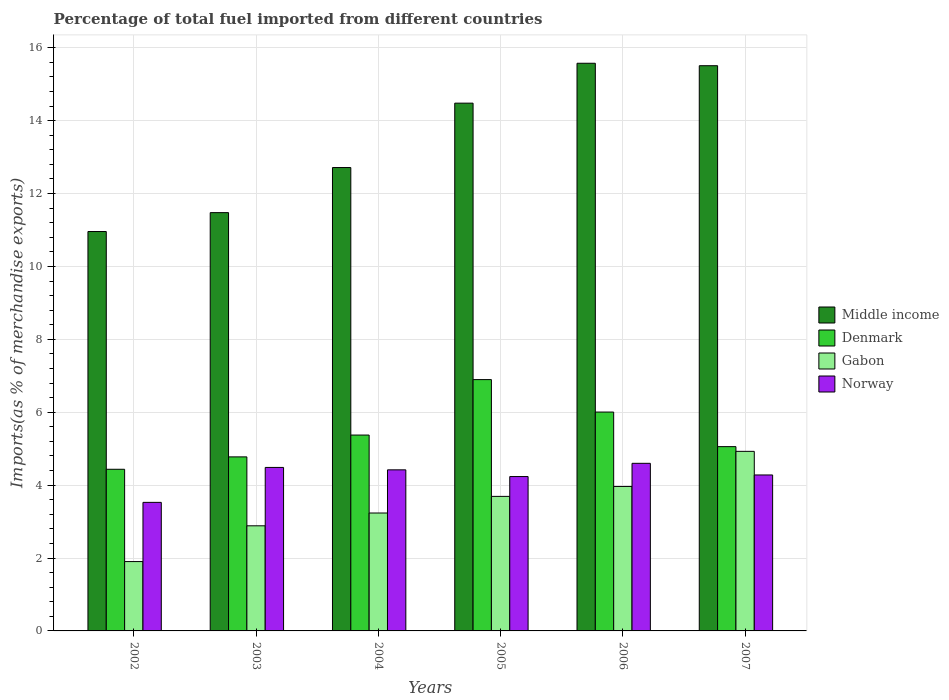How many different coloured bars are there?
Your answer should be compact. 4. How many groups of bars are there?
Provide a short and direct response. 6. Are the number of bars on each tick of the X-axis equal?
Your answer should be compact. Yes. In how many cases, is the number of bars for a given year not equal to the number of legend labels?
Your answer should be very brief. 0. What is the percentage of imports to different countries in Denmark in 2005?
Your response must be concise. 6.9. Across all years, what is the maximum percentage of imports to different countries in Gabon?
Provide a succinct answer. 4.93. Across all years, what is the minimum percentage of imports to different countries in Middle income?
Your response must be concise. 10.96. What is the total percentage of imports to different countries in Denmark in the graph?
Provide a short and direct response. 32.54. What is the difference between the percentage of imports to different countries in Denmark in 2005 and that in 2006?
Your answer should be compact. 0.89. What is the difference between the percentage of imports to different countries in Norway in 2005 and the percentage of imports to different countries in Middle income in 2003?
Provide a succinct answer. -7.24. What is the average percentage of imports to different countries in Middle income per year?
Your response must be concise. 13.45. In the year 2004, what is the difference between the percentage of imports to different countries in Norway and percentage of imports to different countries in Middle income?
Give a very brief answer. -8.29. In how many years, is the percentage of imports to different countries in Gabon greater than 9.6 %?
Give a very brief answer. 0. What is the ratio of the percentage of imports to different countries in Middle income in 2005 to that in 2006?
Your response must be concise. 0.93. Is the difference between the percentage of imports to different countries in Norway in 2004 and 2006 greater than the difference between the percentage of imports to different countries in Middle income in 2004 and 2006?
Make the answer very short. Yes. What is the difference between the highest and the second highest percentage of imports to different countries in Denmark?
Give a very brief answer. 0.89. What is the difference between the highest and the lowest percentage of imports to different countries in Norway?
Keep it short and to the point. 1.07. What does the 4th bar from the left in 2007 represents?
Your response must be concise. Norway. Is it the case that in every year, the sum of the percentage of imports to different countries in Gabon and percentage of imports to different countries in Norway is greater than the percentage of imports to different countries in Denmark?
Your answer should be very brief. Yes. How many bars are there?
Provide a short and direct response. 24. Are all the bars in the graph horizontal?
Provide a succinct answer. No. How many years are there in the graph?
Make the answer very short. 6. What is the difference between two consecutive major ticks on the Y-axis?
Keep it short and to the point. 2. Are the values on the major ticks of Y-axis written in scientific E-notation?
Your answer should be very brief. No. Does the graph contain any zero values?
Give a very brief answer. No. Does the graph contain grids?
Give a very brief answer. Yes. How many legend labels are there?
Ensure brevity in your answer.  4. What is the title of the graph?
Your response must be concise. Percentage of total fuel imported from different countries. What is the label or title of the Y-axis?
Offer a terse response. Imports(as % of merchandise exports). What is the Imports(as % of merchandise exports) in Middle income in 2002?
Ensure brevity in your answer.  10.96. What is the Imports(as % of merchandise exports) of Denmark in 2002?
Provide a succinct answer. 4.44. What is the Imports(as % of merchandise exports) of Gabon in 2002?
Keep it short and to the point. 1.9. What is the Imports(as % of merchandise exports) in Norway in 2002?
Give a very brief answer. 3.53. What is the Imports(as % of merchandise exports) in Middle income in 2003?
Keep it short and to the point. 11.48. What is the Imports(as % of merchandise exports) of Denmark in 2003?
Make the answer very short. 4.77. What is the Imports(as % of merchandise exports) of Gabon in 2003?
Provide a short and direct response. 2.88. What is the Imports(as % of merchandise exports) of Norway in 2003?
Your answer should be very brief. 4.49. What is the Imports(as % of merchandise exports) in Middle income in 2004?
Provide a succinct answer. 12.71. What is the Imports(as % of merchandise exports) in Denmark in 2004?
Your answer should be very brief. 5.37. What is the Imports(as % of merchandise exports) of Gabon in 2004?
Provide a short and direct response. 3.23. What is the Imports(as % of merchandise exports) of Norway in 2004?
Make the answer very short. 4.42. What is the Imports(as % of merchandise exports) in Middle income in 2005?
Give a very brief answer. 14.48. What is the Imports(as % of merchandise exports) of Denmark in 2005?
Your answer should be very brief. 6.9. What is the Imports(as % of merchandise exports) in Gabon in 2005?
Your answer should be very brief. 3.69. What is the Imports(as % of merchandise exports) in Norway in 2005?
Offer a terse response. 4.24. What is the Imports(as % of merchandise exports) in Middle income in 2006?
Provide a succinct answer. 15.57. What is the Imports(as % of merchandise exports) in Denmark in 2006?
Offer a terse response. 6. What is the Imports(as % of merchandise exports) of Gabon in 2006?
Make the answer very short. 3.96. What is the Imports(as % of merchandise exports) in Norway in 2006?
Provide a short and direct response. 4.6. What is the Imports(as % of merchandise exports) of Middle income in 2007?
Offer a terse response. 15.51. What is the Imports(as % of merchandise exports) of Denmark in 2007?
Ensure brevity in your answer.  5.06. What is the Imports(as % of merchandise exports) in Gabon in 2007?
Provide a short and direct response. 4.93. What is the Imports(as % of merchandise exports) in Norway in 2007?
Ensure brevity in your answer.  4.28. Across all years, what is the maximum Imports(as % of merchandise exports) of Middle income?
Make the answer very short. 15.57. Across all years, what is the maximum Imports(as % of merchandise exports) of Denmark?
Offer a very short reply. 6.9. Across all years, what is the maximum Imports(as % of merchandise exports) of Gabon?
Provide a short and direct response. 4.93. Across all years, what is the maximum Imports(as % of merchandise exports) of Norway?
Keep it short and to the point. 4.6. Across all years, what is the minimum Imports(as % of merchandise exports) of Middle income?
Give a very brief answer. 10.96. Across all years, what is the minimum Imports(as % of merchandise exports) of Denmark?
Your response must be concise. 4.44. Across all years, what is the minimum Imports(as % of merchandise exports) in Gabon?
Provide a succinct answer. 1.9. Across all years, what is the minimum Imports(as % of merchandise exports) in Norway?
Offer a very short reply. 3.53. What is the total Imports(as % of merchandise exports) in Middle income in the graph?
Offer a very short reply. 80.71. What is the total Imports(as % of merchandise exports) in Denmark in the graph?
Give a very brief answer. 32.54. What is the total Imports(as % of merchandise exports) in Gabon in the graph?
Offer a very short reply. 20.6. What is the total Imports(as % of merchandise exports) of Norway in the graph?
Provide a succinct answer. 25.54. What is the difference between the Imports(as % of merchandise exports) in Middle income in 2002 and that in 2003?
Your answer should be very brief. -0.52. What is the difference between the Imports(as % of merchandise exports) of Denmark in 2002 and that in 2003?
Your answer should be very brief. -0.34. What is the difference between the Imports(as % of merchandise exports) in Gabon in 2002 and that in 2003?
Offer a very short reply. -0.98. What is the difference between the Imports(as % of merchandise exports) of Norway in 2002 and that in 2003?
Offer a very short reply. -0.96. What is the difference between the Imports(as % of merchandise exports) in Middle income in 2002 and that in 2004?
Your answer should be very brief. -1.76. What is the difference between the Imports(as % of merchandise exports) in Denmark in 2002 and that in 2004?
Your answer should be compact. -0.94. What is the difference between the Imports(as % of merchandise exports) in Gabon in 2002 and that in 2004?
Ensure brevity in your answer.  -1.33. What is the difference between the Imports(as % of merchandise exports) of Norway in 2002 and that in 2004?
Provide a short and direct response. -0.89. What is the difference between the Imports(as % of merchandise exports) of Middle income in 2002 and that in 2005?
Ensure brevity in your answer.  -3.52. What is the difference between the Imports(as % of merchandise exports) of Denmark in 2002 and that in 2005?
Ensure brevity in your answer.  -2.46. What is the difference between the Imports(as % of merchandise exports) in Gabon in 2002 and that in 2005?
Provide a short and direct response. -1.79. What is the difference between the Imports(as % of merchandise exports) in Norway in 2002 and that in 2005?
Give a very brief answer. -0.71. What is the difference between the Imports(as % of merchandise exports) in Middle income in 2002 and that in 2006?
Your response must be concise. -4.62. What is the difference between the Imports(as % of merchandise exports) in Denmark in 2002 and that in 2006?
Give a very brief answer. -1.57. What is the difference between the Imports(as % of merchandise exports) of Gabon in 2002 and that in 2006?
Ensure brevity in your answer.  -2.06. What is the difference between the Imports(as % of merchandise exports) of Norway in 2002 and that in 2006?
Your answer should be compact. -1.07. What is the difference between the Imports(as % of merchandise exports) of Middle income in 2002 and that in 2007?
Ensure brevity in your answer.  -4.55. What is the difference between the Imports(as % of merchandise exports) of Denmark in 2002 and that in 2007?
Make the answer very short. -0.62. What is the difference between the Imports(as % of merchandise exports) in Gabon in 2002 and that in 2007?
Provide a short and direct response. -3.02. What is the difference between the Imports(as % of merchandise exports) of Norway in 2002 and that in 2007?
Offer a terse response. -0.75. What is the difference between the Imports(as % of merchandise exports) in Middle income in 2003 and that in 2004?
Your answer should be very brief. -1.24. What is the difference between the Imports(as % of merchandise exports) in Denmark in 2003 and that in 2004?
Give a very brief answer. -0.6. What is the difference between the Imports(as % of merchandise exports) of Gabon in 2003 and that in 2004?
Offer a very short reply. -0.35. What is the difference between the Imports(as % of merchandise exports) of Norway in 2003 and that in 2004?
Keep it short and to the point. 0.07. What is the difference between the Imports(as % of merchandise exports) in Middle income in 2003 and that in 2005?
Offer a very short reply. -3. What is the difference between the Imports(as % of merchandise exports) in Denmark in 2003 and that in 2005?
Ensure brevity in your answer.  -2.12. What is the difference between the Imports(as % of merchandise exports) of Gabon in 2003 and that in 2005?
Offer a terse response. -0.81. What is the difference between the Imports(as % of merchandise exports) in Norway in 2003 and that in 2005?
Offer a very short reply. 0.25. What is the difference between the Imports(as % of merchandise exports) of Middle income in 2003 and that in 2006?
Ensure brevity in your answer.  -4.1. What is the difference between the Imports(as % of merchandise exports) of Denmark in 2003 and that in 2006?
Your answer should be compact. -1.23. What is the difference between the Imports(as % of merchandise exports) of Gabon in 2003 and that in 2006?
Provide a succinct answer. -1.08. What is the difference between the Imports(as % of merchandise exports) in Norway in 2003 and that in 2006?
Offer a very short reply. -0.11. What is the difference between the Imports(as % of merchandise exports) of Middle income in 2003 and that in 2007?
Your response must be concise. -4.03. What is the difference between the Imports(as % of merchandise exports) of Denmark in 2003 and that in 2007?
Your answer should be compact. -0.28. What is the difference between the Imports(as % of merchandise exports) of Gabon in 2003 and that in 2007?
Provide a short and direct response. -2.04. What is the difference between the Imports(as % of merchandise exports) in Norway in 2003 and that in 2007?
Offer a terse response. 0.21. What is the difference between the Imports(as % of merchandise exports) in Middle income in 2004 and that in 2005?
Ensure brevity in your answer.  -1.77. What is the difference between the Imports(as % of merchandise exports) in Denmark in 2004 and that in 2005?
Make the answer very short. -1.52. What is the difference between the Imports(as % of merchandise exports) of Gabon in 2004 and that in 2005?
Give a very brief answer. -0.46. What is the difference between the Imports(as % of merchandise exports) in Norway in 2004 and that in 2005?
Your answer should be very brief. 0.18. What is the difference between the Imports(as % of merchandise exports) in Middle income in 2004 and that in 2006?
Give a very brief answer. -2.86. What is the difference between the Imports(as % of merchandise exports) of Denmark in 2004 and that in 2006?
Offer a terse response. -0.63. What is the difference between the Imports(as % of merchandise exports) of Gabon in 2004 and that in 2006?
Provide a short and direct response. -0.73. What is the difference between the Imports(as % of merchandise exports) of Norway in 2004 and that in 2006?
Offer a very short reply. -0.18. What is the difference between the Imports(as % of merchandise exports) of Middle income in 2004 and that in 2007?
Keep it short and to the point. -2.79. What is the difference between the Imports(as % of merchandise exports) of Denmark in 2004 and that in 2007?
Offer a very short reply. 0.32. What is the difference between the Imports(as % of merchandise exports) of Gabon in 2004 and that in 2007?
Keep it short and to the point. -1.69. What is the difference between the Imports(as % of merchandise exports) in Norway in 2004 and that in 2007?
Your answer should be very brief. 0.14. What is the difference between the Imports(as % of merchandise exports) of Middle income in 2005 and that in 2006?
Offer a very short reply. -1.09. What is the difference between the Imports(as % of merchandise exports) of Denmark in 2005 and that in 2006?
Offer a very short reply. 0.89. What is the difference between the Imports(as % of merchandise exports) in Gabon in 2005 and that in 2006?
Provide a short and direct response. -0.27. What is the difference between the Imports(as % of merchandise exports) of Norway in 2005 and that in 2006?
Make the answer very short. -0.36. What is the difference between the Imports(as % of merchandise exports) of Middle income in 2005 and that in 2007?
Keep it short and to the point. -1.03. What is the difference between the Imports(as % of merchandise exports) in Denmark in 2005 and that in 2007?
Your answer should be very brief. 1.84. What is the difference between the Imports(as % of merchandise exports) of Gabon in 2005 and that in 2007?
Make the answer very short. -1.24. What is the difference between the Imports(as % of merchandise exports) of Norway in 2005 and that in 2007?
Your response must be concise. -0.04. What is the difference between the Imports(as % of merchandise exports) of Middle income in 2006 and that in 2007?
Your response must be concise. 0.07. What is the difference between the Imports(as % of merchandise exports) in Denmark in 2006 and that in 2007?
Give a very brief answer. 0.95. What is the difference between the Imports(as % of merchandise exports) of Gabon in 2006 and that in 2007?
Make the answer very short. -0.96. What is the difference between the Imports(as % of merchandise exports) in Norway in 2006 and that in 2007?
Provide a succinct answer. 0.32. What is the difference between the Imports(as % of merchandise exports) in Middle income in 2002 and the Imports(as % of merchandise exports) in Denmark in 2003?
Give a very brief answer. 6.18. What is the difference between the Imports(as % of merchandise exports) in Middle income in 2002 and the Imports(as % of merchandise exports) in Gabon in 2003?
Give a very brief answer. 8.07. What is the difference between the Imports(as % of merchandise exports) in Middle income in 2002 and the Imports(as % of merchandise exports) in Norway in 2003?
Give a very brief answer. 6.47. What is the difference between the Imports(as % of merchandise exports) of Denmark in 2002 and the Imports(as % of merchandise exports) of Gabon in 2003?
Give a very brief answer. 1.55. What is the difference between the Imports(as % of merchandise exports) of Denmark in 2002 and the Imports(as % of merchandise exports) of Norway in 2003?
Your response must be concise. -0.05. What is the difference between the Imports(as % of merchandise exports) of Gabon in 2002 and the Imports(as % of merchandise exports) of Norway in 2003?
Ensure brevity in your answer.  -2.58. What is the difference between the Imports(as % of merchandise exports) of Middle income in 2002 and the Imports(as % of merchandise exports) of Denmark in 2004?
Make the answer very short. 5.58. What is the difference between the Imports(as % of merchandise exports) in Middle income in 2002 and the Imports(as % of merchandise exports) in Gabon in 2004?
Give a very brief answer. 7.72. What is the difference between the Imports(as % of merchandise exports) in Middle income in 2002 and the Imports(as % of merchandise exports) in Norway in 2004?
Your answer should be compact. 6.54. What is the difference between the Imports(as % of merchandise exports) of Denmark in 2002 and the Imports(as % of merchandise exports) of Gabon in 2004?
Keep it short and to the point. 1.2. What is the difference between the Imports(as % of merchandise exports) in Denmark in 2002 and the Imports(as % of merchandise exports) in Norway in 2004?
Make the answer very short. 0.02. What is the difference between the Imports(as % of merchandise exports) of Gabon in 2002 and the Imports(as % of merchandise exports) of Norway in 2004?
Offer a very short reply. -2.52. What is the difference between the Imports(as % of merchandise exports) of Middle income in 2002 and the Imports(as % of merchandise exports) of Denmark in 2005?
Offer a terse response. 4.06. What is the difference between the Imports(as % of merchandise exports) in Middle income in 2002 and the Imports(as % of merchandise exports) in Gabon in 2005?
Provide a short and direct response. 7.27. What is the difference between the Imports(as % of merchandise exports) of Middle income in 2002 and the Imports(as % of merchandise exports) of Norway in 2005?
Provide a short and direct response. 6.72. What is the difference between the Imports(as % of merchandise exports) of Denmark in 2002 and the Imports(as % of merchandise exports) of Gabon in 2005?
Ensure brevity in your answer.  0.74. What is the difference between the Imports(as % of merchandise exports) of Denmark in 2002 and the Imports(as % of merchandise exports) of Norway in 2005?
Keep it short and to the point. 0.2. What is the difference between the Imports(as % of merchandise exports) of Gabon in 2002 and the Imports(as % of merchandise exports) of Norway in 2005?
Make the answer very short. -2.33. What is the difference between the Imports(as % of merchandise exports) of Middle income in 2002 and the Imports(as % of merchandise exports) of Denmark in 2006?
Give a very brief answer. 4.95. What is the difference between the Imports(as % of merchandise exports) of Middle income in 2002 and the Imports(as % of merchandise exports) of Gabon in 2006?
Your response must be concise. 6.99. What is the difference between the Imports(as % of merchandise exports) of Middle income in 2002 and the Imports(as % of merchandise exports) of Norway in 2006?
Your answer should be very brief. 6.36. What is the difference between the Imports(as % of merchandise exports) of Denmark in 2002 and the Imports(as % of merchandise exports) of Gabon in 2006?
Offer a very short reply. 0.47. What is the difference between the Imports(as % of merchandise exports) of Denmark in 2002 and the Imports(as % of merchandise exports) of Norway in 2006?
Offer a very short reply. -0.16. What is the difference between the Imports(as % of merchandise exports) of Gabon in 2002 and the Imports(as % of merchandise exports) of Norway in 2006?
Your answer should be very brief. -2.7. What is the difference between the Imports(as % of merchandise exports) of Middle income in 2002 and the Imports(as % of merchandise exports) of Denmark in 2007?
Give a very brief answer. 5.9. What is the difference between the Imports(as % of merchandise exports) in Middle income in 2002 and the Imports(as % of merchandise exports) in Gabon in 2007?
Offer a terse response. 6.03. What is the difference between the Imports(as % of merchandise exports) of Middle income in 2002 and the Imports(as % of merchandise exports) of Norway in 2007?
Give a very brief answer. 6.68. What is the difference between the Imports(as % of merchandise exports) of Denmark in 2002 and the Imports(as % of merchandise exports) of Gabon in 2007?
Provide a short and direct response. -0.49. What is the difference between the Imports(as % of merchandise exports) of Denmark in 2002 and the Imports(as % of merchandise exports) of Norway in 2007?
Your answer should be very brief. 0.16. What is the difference between the Imports(as % of merchandise exports) of Gabon in 2002 and the Imports(as % of merchandise exports) of Norway in 2007?
Keep it short and to the point. -2.38. What is the difference between the Imports(as % of merchandise exports) in Middle income in 2003 and the Imports(as % of merchandise exports) in Denmark in 2004?
Your response must be concise. 6.1. What is the difference between the Imports(as % of merchandise exports) in Middle income in 2003 and the Imports(as % of merchandise exports) in Gabon in 2004?
Offer a terse response. 8.24. What is the difference between the Imports(as % of merchandise exports) of Middle income in 2003 and the Imports(as % of merchandise exports) of Norway in 2004?
Give a very brief answer. 7.06. What is the difference between the Imports(as % of merchandise exports) in Denmark in 2003 and the Imports(as % of merchandise exports) in Gabon in 2004?
Offer a very short reply. 1.54. What is the difference between the Imports(as % of merchandise exports) of Denmark in 2003 and the Imports(as % of merchandise exports) of Norway in 2004?
Give a very brief answer. 0.36. What is the difference between the Imports(as % of merchandise exports) of Gabon in 2003 and the Imports(as % of merchandise exports) of Norway in 2004?
Make the answer very short. -1.54. What is the difference between the Imports(as % of merchandise exports) of Middle income in 2003 and the Imports(as % of merchandise exports) of Denmark in 2005?
Provide a succinct answer. 4.58. What is the difference between the Imports(as % of merchandise exports) in Middle income in 2003 and the Imports(as % of merchandise exports) in Gabon in 2005?
Ensure brevity in your answer.  7.78. What is the difference between the Imports(as % of merchandise exports) of Middle income in 2003 and the Imports(as % of merchandise exports) of Norway in 2005?
Your answer should be compact. 7.24. What is the difference between the Imports(as % of merchandise exports) in Denmark in 2003 and the Imports(as % of merchandise exports) in Gabon in 2005?
Keep it short and to the point. 1.08. What is the difference between the Imports(as % of merchandise exports) in Denmark in 2003 and the Imports(as % of merchandise exports) in Norway in 2005?
Your response must be concise. 0.54. What is the difference between the Imports(as % of merchandise exports) in Gabon in 2003 and the Imports(as % of merchandise exports) in Norway in 2005?
Your response must be concise. -1.35. What is the difference between the Imports(as % of merchandise exports) of Middle income in 2003 and the Imports(as % of merchandise exports) of Denmark in 2006?
Offer a very short reply. 5.47. What is the difference between the Imports(as % of merchandise exports) of Middle income in 2003 and the Imports(as % of merchandise exports) of Gabon in 2006?
Make the answer very short. 7.51. What is the difference between the Imports(as % of merchandise exports) of Middle income in 2003 and the Imports(as % of merchandise exports) of Norway in 2006?
Make the answer very short. 6.88. What is the difference between the Imports(as % of merchandise exports) in Denmark in 2003 and the Imports(as % of merchandise exports) in Gabon in 2006?
Provide a succinct answer. 0.81. What is the difference between the Imports(as % of merchandise exports) of Denmark in 2003 and the Imports(as % of merchandise exports) of Norway in 2006?
Offer a terse response. 0.18. What is the difference between the Imports(as % of merchandise exports) in Gabon in 2003 and the Imports(as % of merchandise exports) in Norway in 2006?
Your response must be concise. -1.71. What is the difference between the Imports(as % of merchandise exports) of Middle income in 2003 and the Imports(as % of merchandise exports) of Denmark in 2007?
Offer a terse response. 6.42. What is the difference between the Imports(as % of merchandise exports) in Middle income in 2003 and the Imports(as % of merchandise exports) in Gabon in 2007?
Give a very brief answer. 6.55. What is the difference between the Imports(as % of merchandise exports) in Middle income in 2003 and the Imports(as % of merchandise exports) in Norway in 2007?
Your answer should be very brief. 7.2. What is the difference between the Imports(as % of merchandise exports) of Denmark in 2003 and the Imports(as % of merchandise exports) of Gabon in 2007?
Provide a short and direct response. -0.15. What is the difference between the Imports(as % of merchandise exports) in Denmark in 2003 and the Imports(as % of merchandise exports) in Norway in 2007?
Offer a terse response. 0.5. What is the difference between the Imports(as % of merchandise exports) of Gabon in 2003 and the Imports(as % of merchandise exports) of Norway in 2007?
Ensure brevity in your answer.  -1.4. What is the difference between the Imports(as % of merchandise exports) of Middle income in 2004 and the Imports(as % of merchandise exports) of Denmark in 2005?
Your answer should be compact. 5.82. What is the difference between the Imports(as % of merchandise exports) of Middle income in 2004 and the Imports(as % of merchandise exports) of Gabon in 2005?
Ensure brevity in your answer.  9.02. What is the difference between the Imports(as % of merchandise exports) in Middle income in 2004 and the Imports(as % of merchandise exports) in Norway in 2005?
Your answer should be very brief. 8.48. What is the difference between the Imports(as % of merchandise exports) in Denmark in 2004 and the Imports(as % of merchandise exports) in Gabon in 2005?
Provide a succinct answer. 1.68. What is the difference between the Imports(as % of merchandise exports) of Denmark in 2004 and the Imports(as % of merchandise exports) of Norway in 2005?
Provide a short and direct response. 1.14. What is the difference between the Imports(as % of merchandise exports) in Gabon in 2004 and the Imports(as % of merchandise exports) in Norway in 2005?
Give a very brief answer. -1. What is the difference between the Imports(as % of merchandise exports) of Middle income in 2004 and the Imports(as % of merchandise exports) of Denmark in 2006?
Offer a very short reply. 6.71. What is the difference between the Imports(as % of merchandise exports) of Middle income in 2004 and the Imports(as % of merchandise exports) of Gabon in 2006?
Provide a short and direct response. 8.75. What is the difference between the Imports(as % of merchandise exports) of Middle income in 2004 and the Imports(as % of merchandise exports) of Norway in 2006?
Your response must be concise. 8.12. What is the difference between the Imports(as % of merchandise exports) in Denmark in 2004 and the Imports(as % of merchandise exports) in Gabon in 2006?
Keep it short and to the point. 1.41. What is the difference between the Imports(as % of merchandise exports) of Denmark in 2004 and the Imports(as % of merchandise exports) of Norway in 2006?
Provide a short and direct response. 0.78. What is the difference between the Imports(as % of merchandise exports) in Gabon in 2004 and the Imports(as % of merchandise exports) in Norway in 2006?
Your response must be concise. -1.36. What is the difference between the Imports(as % of merchandise exports) in Middle income in 2004 and the Imports(as % of merchandise exports) in Denmark in 2007?
Your answer should be compact. 7.66. What is the difference between the Imports(as % of merchandise exports) in Middle income in 2004 and the Imports(as % of merchandise exports) in Gabon in 2007?
Provide a short and direct response. 7.79. What is the difference between the Imports(as % of merchandise exports) in Middle income in 2004 and the Imports(as % of merchandise exports) in Norway in 2007?
Your response must be concise. 8.43. What is the difference between the Imports(as % of merchandise exports) in Denmark in 2004 and the Imports(as % of merchandise exports) in Gabon in 2007?
Your answer should be very brief. 0.45. What is the difference between the Imports(as % of merchandise exports) in Denmark in 2004 and the Imports(as % of merchandise exports) in Norway in 2007?
Your answer should be compact. 1.09. What is the difference between the Imports(as % of merchandise exports) in Gabon in 2004 and the Imports(as % of merchandise exports) in Norway in 2007?
Offer a terse response. -1.04. What is the difference between the Imports(as % of merchandise exports) of Middle income in 2005 and the Imports(as % of merchandise exports) of Denmark in 2006?
Provide a short and direct response. 8.48. What is the difference between the Imports(as % of merchandise exports) of Middle income in 2005 and the Imports(as % of merchandise exports) of Gabon in 2006?
Give a very brief answer. 10.52. What is the difference between the Imports(as % of merchandise exports) of Middle income in 2005 and the Imports(as % of merchandise exports) of Norway in 2006?
Provide a succinct answer. 9.88. What is the difference between the Imports(as % of merchandise exports) in Denmark in 2005 and the Imports(as % of merchandise exports) in Gabon in 2006?
Your answer should be compact. 2.93. What is the difference between the Imports(as % of merchandise exports) of Denmark in 2005 and the Imports(as % of merchandise exports) of Norway in 2006?
Ensure brevity in your answer.  2.3. What is the difference between the Imports(as % of merchandise exports) of Gabon in 2005 and the Imports(as % of merchandise exports) of Norway in 2006?
Offer a very short reply. -0.91. What is the difference between the Imports(as % of merchandise exports) in Middle income in 2005 and the Imports(as % of merchandise exports) in Denmark in 2007?
Ensure brevity in your answer.  9.42. What is the difference between the Imports(as % of merchandise exports) in Middle income in 2005 and the Imports(as % of merchandise exports) in Gabon in 2007?
Your response must be concise. 9.55. What is the difference between the Imports(as % of merchandise exports) of Middle income in 2005 and the Imports(as % of merchandise exports) of Norway in 2007?
Your answer should be compact. 10.2. What is the difference between the Imports(as % of merchandise exports) in Denmark in 2005 and the Imports(as % of merchandise exports) in Gabon in 2007?
Provide a short and direct response. 1.97. What is the difference between the Imports(as % of merchandise exports) in Denmark in 2005 and the Imports(as % of merchandise exports) in Norway in 2007?
Give a very brief answer. 2.62. What is the difference between the Imports(as % of merchandise exports) in Gabon in 2005 and the Imports(as % of merchandise exports) in Norway in 2007?
Provide a short and direct response. -0.59. What is the difference between the Imports(as % of merchandise exports) in Middle income in 2006 and the Imports(as % of merchandise exports) in Denmark in 2007?
Provide a succinct answer. 10.52. What is the difference between the Imports(as % of merchandise exports) in Middle income in 2006 and the Imports(as % of merchandise exports) in Gabon in 2007?
Ensure brevity in your answer.  10.65. What is the difference between the Imports(as % of merchandise exports) of Middle income in 2006 and the Imports(as % of merchandise exports) of Norway in 2007?
Keep it short and to the point. 11.3. What is the difference between the Imports(as % of merchandise exports) in Denmark in 2006 and the Imports(as % of merchandise exports) in Gabon in 2007?
Ensure brevity in your answer.  1.08. What is the difference between the Imports(as % of merchandise exports) of Denmark in 2006 and the Imports(as % of merchandise exports) of Norway in 2007?
Ensure brevity in your answer.  1.73. What is the difference between the Imports(as % of merchandise exports) in Gabon in 2006 and the Imports(as % of merchandise exports) in Norway in 2007?
Your answer should be compact. -0.32. What is the average Imports(as % of merchandise exports) of Middle income per year?
Offer a terse response. 13.45. What is the average Imports(as % of merchandise exports) of Denmark per year?
Provide a succinct answer. 5.42. What is the average Imports(as % of merchandise exports) of Gabon per year?
Make the answer very short. 3.43. What is the average Imports(as % of merchandise exports) in Norway per year?
Offer a terse response. 4.26. In the year 2002, what is the difference between the Imports(as % of merchandise exports) in Middle income and Imports(as % of merchandise exports) in Denmark?
Offer a terse response. 6.52. In the year 2002, what is the difference between the Imports(as % of merchandise exports) of Middle income and Imports(as % of merchandise exports) of Gabon?
Offer a very short reply. 9.06. In the year 2002, what is the difference between the Imports(as % of merchandise exports) in Middle income and Imports(as % of merchandise exports) in Norway?
Provide a succinct answer. 7.43. In the year 2002, what is the difference between the Imports(as % of merchandise exports) of Denmark and Imports(as % of merchandise exports) of Gabon?
Offer a terse response. 2.53. In the year 2002, what is the difference between the Imports(as % of merchandise exports) of Denmark and Imports(as % of merchandise exports) of Norway?
Provide a succinct answer. 0.91. In the year 2002, what is the difference between the Imports(as % of merchandise exports) of Gabon and Imports(as % of merchandise exports) of Norway?
Provide a succinct answer. -1.62. In the year 2003, what is the difference between the Imports(as % of merchandise exports) of Middle income and Imports(as % of merchandise exports) of Denmark?
Your answer should be compact. 6.7. In the year 2003, what is the difference between the Imports(as % of merchandise exports) of Middle income and Imports(as % of merchandise exports) of Gabon?
Make the answer very short. 8.59. In the year 2003, what is the difference between the Imports(as % of merchandise exports) in Middle income and Imports(as % of merchandise exports) in Norway?
Give a very brief answer. 6.99. In the year 2003, what is the difference between the Imports(as % of merchandise exports) in Denmark and Imports(as % of merchandise exports) in Gabon?
Your response must be concise. 1.89. In the year 2003, what is the difference between the Imports(as % of merchandise exports) of Denmark and Imports(as % of merchandise exports) of Norway?
Make the answer very short. 0.29. In the year 2003, what is the difference between the Imports(as % of merchandise exports) in Gabon and Imports(as % of merchandise exports) in Norway?
Your answer should be compact. -1.6. In the year 2004, what is the difference between the Imports(as % of merchandise exports) in Middle income and Imports(as % of merchandise exports) in Denmark?
Your answer should be compact. 7.34. In the year 2004, what is the difference between the Imports(as % of merchandise exports) in Middle income and Imports(as % of merchandise exports) in Gabon?
Offer a terse response. 9.48. In the year 2004, what is the difference between the Imports(as % of merchandise exports) in Middle income and Imports(as % of merchandise exports) in Norway?
Provide a short and direct response. 8.29. In the year 2004, what is the difference between the Imports(as % of merchandise exports) in Denmark and Imports(as % of merchandise exports) in Gabon?
Your answer should be very brief. 2.14. In the year 2004, what is the difference between the Imports(as % of merchandise exports) of Denmark and Imports(as % of merchandise exports) of Norway?
Make the answer very short. 0.95. In the year 2004, what is the difference between the Imports(as % of merchandise exports) in Gabon and Imports(as % of merchandise exports) in Norway?
Offer a very short reply. -1.18. In the year 2005, what is the difference between the Imports(as % of merchandise exports) of Middle income and Imports(as % of merchandise exports) of Denmark?
Provide a succinct answer. 7.58. In the year 2005, what is the difference between the Imports(as % of merchandise exports) of Middle income and Imports(as % of merchandise exports) of Gabon?
Offer a terse response. 10.79. In the year 2005, what is the difference between the Imports(as % of merchandise exports) of Middle income and Imports(as % of merchandise exports) of Norway?
Ensure brevity in your answer.  10.24. In the year 2005, what is the difference between the Imports(as % of merchandise exports) in Denmark and Imports(as % of merchandise exports) in Gabon?
Offer a very short reply. 3.2. In the year 2005, what is the difference between the Imports(as % of merchandise exports) of Denmark and Imports(as % of merchandise exports) of Norway?
Make the answer very short. 2.66. In the year 2005, what is the difference between the Imports(as % of merchandise exports) in Gabon and Imports(as % of merchandise exports) in Norway?
Offer a terse response. -0.54. In the year 2006, what is the difference between the Imports(as % of merchandise exports) of Middle income and Imports(as % of merchandise exports) of Denmark?
Your answer should be compact. 9.57. In the year 2006, what is the difference between the Imports(as % of merchandise exports) in Middle income and Imports(as % of merchandise exports) in Gabon?
Your answer should be very brief. 11.61. In the year 2006, what is the difference between the Imports(as % of merchandise exports) in Middle income and Imports(as % of merchandise exports) in Norway?
Give a very brief answer. 10.98. In the year 2006, what is the difference between the Imports(as % of merchandise exports) in Denmark and Imports(as % of merchandise exports) in Gabon?
Provide a short and direct response. 2.04. In the year 2006, what is the difference between the Imports(as % of merchandise exports) in Denmark and Imports(as % of merchandise exports) in Norway?
Your answer should be very brief. 1.41. In the year 2006, what is the difference between the Imports(as % of merchandise exports) of Gabon and Imports(as % of merchandise exports) of Norway?
Ensure brevity in your answer.  -0.63. In the year 2007, what is the difference between the Imports(as % of merchandise exports) in Middle income and Imports(as % of merchandise exports) in Denmark?
Offer a very short reply. 10.45. In the year 2007, what is the difference between the Imports(as % of merchandise exports) in Middle income and Imports(as % of merchandise exports) in Gabon?
Your answer should be compact. 10.58. In the year 2007, what is the difference between the Imports(as % of merchandise exports) of Middle income and Imports(as % of merchandise exports) of Norway?
Make the answer very short. 11.23. In the year 2007, what is the difference between the Imports(as % of merchandise exports) of Denmark and Imports(as % of merchandise exports) of Gabon?
Offer a very short reply. 0.13. In the year 2007, what is the difference between the Imports(as % of merchandise exports) of Denmark and Imports(as % of merchandise exports) of Norway?
Ensure brevity in your answer.  0.78. In the year 2007, what is the difference between the Imports(as % of merchandise exports) of Gabon and Imports(as % of merchandise exports) of Norway?
Give a very brief answer. 0.65. What is the ratio of the Imports(as % of merchandise exports) in Middle income in 2002 to that in 2003?
Make the answer very short. 0.95. What is the ratio of the Imports(as % of merchandise exports) in Denmark in 2002 to that in 2003?
Offer a very short reply. 0.93. What is the ratio of the Imports(as % of merchandise exports) of Gabon in 2002 to that in 2003?
Provide a succinct answer. 0.66. What is the ratio of the Imports(as % of merchandise exports) in Norway in 2002 to that in 2003?
Keep it short and to the point. 0.79. What is the ratio of the Imports(as % of merchandise exports) of Middle income in 2002 to that in 2004?
Offer a very short reply. 0.86. What is the ratio of the Imports(as % of merchandise exports) of Denmark in 2002 to that in 2004?
Provide a short and direct response. 0.83. What is the ratio of the Imports(as % of merchandise exports) of Gabon in 2002 to that in 2004?
Keep it short and to the point. 0.59. What is the ratio of the Imports(as % of merchandise exports) in Norway in 2002 to that in 2004?
Ensure brevity in your answer.  0.8. What is the ratio of the Imports(as % of merchandise exports) in Middle income in 2002 to that in 2005?
Give a very brief answer. 0.76. What is the ratio of the Imports(as % of merchandise exports) of Denmark in 2002 to that in 2005?
Provide a succinct answer. 0.64. What is the ratio of the Imports(as % of merchandise exports) in Gabon in 2002 to that in 2005?
Keep it short and to the point. 0.52. What is the ratio of the Imports(as % of merchandise exports) in Norway in 2002 to that in 2005?
Offer a terse response. 0.83. What is the ratio of the Imports(as % of merchandise exports) in Middle income in 2002 to that in 2006?
Ensure brevity in your answer.  0.7. What is the ratio of the Imports(as % of merchandise exports) in Denmark in 2002 to that in 2006?
Provide a short and direct response. 0.74. What is the ratio of the Imports(as % of merchandise exports) of Gabon in 2002 to that in 2006?
Offer a terse response. 0.48. What is the ratio of the Imports(as % of merchandise exports) in Norway in 2002 to that in 2006?
Your answer should be very brief. 0.77. What is the ratio of the Imports(as % of merchandise exports) of Middle income in 2002 to that in 2007?
Your answer should be compact. 0.71. What is the ratio of the Imports(as % of merchandise exports) of Denmark in 2002 to that in 2007?
Keep it short and to the point. 0.88. What is the ratio of the Imports(as % of merchandise exports) of Gabon in 2002 to that in 2007?
Offer a terse response. 0.39. What is the ratio of the Imports(as % of merchandise exports) in Norway in 2002 to that in 2007?
Your answer should be compact. 0.82. What is the ratio of the Imports(as % of merchandise exports) in Middle income in 2003 to that in 2004?
Keep it short and to the point. 0.9. What is the ratio of the Imports(as % of merchandise exports) of Denmark in 2003 to that in 2004?
Your answer should be compact. 0.89. What is the ratio of the Imports(as % of merchandise exports) of Gabon in 2003 to that in 2004?
Your answer should be compact. 0.89. What is the ratio of the Imports(as % of merchandise exports) of Norway in 2003 to that in 2004?
Keep it short and to the point. 1.01. What is the ratio of the Imports(as % of merchandise exports) of Middle income in 2003 to that in 2005?
Make the answer very short. 0.79. What is the ratio of the Imports(as % of merchandise exports) in Denmark in 2003 to that in 2005?
Keep it short and to the point. 0.69. What is the ratio of the Imports(as % of merchandise exports) of Gabon in 2003 to that in 2005?
Your answer should be compact. 0.78. What is the ratio of the Imports(as % of merchandise exports) of Norway in 2003 to that in 2005?
Provide a succinct answer. 1.06. What is the ratio of the Imports(as % of merchandise exports) of Middle income in 2003 to that in 2006?
Provide a short and direct response. 0.74. What is the ratio of the Imports(as % of merchandise exports) of Denmark in 2003 to that in 2006?
Your answer should be compact. 0.8. What is the ratio of the Imports(as % of merchandise exports) in Gabon in 2003 to that in 2006?
Provide a short and direct response. 0.73. What is the ratio of the Imports(as % of merchandise exports) of Norway in 2003 to that in 2006?
Make the answer very short. 0.98. What is the ratio of the Imports(as % of merchandise exports) in Middle income in 2003 to that in 2007?
Make the answer very short. 0.74. What is the ratio of the Imports(as % of merchandise exports) of Denmark in 2003 to that in 2007?
Provide a short and direct response. 0.94. What is the ratio of the Imports(as % of merchandise exports) of Gabon in 2003 to that in 2007?
Your response must be concise. 0.59. What is the ratio of the Imports(as % of merchandise exports) of Norway in 2003 to that in 2007?
Provide a short and direct response. 1.05. What is the ratio of the Imports(as % of merchandise exports) of Middle income in 2004 to that in 2005?
Offer a terse response. 0.88. What is the ratio of the Imports(as % of merchandise exports) of Denmark in 2004 to that in 2005?
Your response must be concise. 0.78. What is the ratio of the Imports(as % of merchandise exports) of Gabon in 2004 to that in 2005?
Provide a succinct answer. 0.88. What is the ratio of the Imports(as % of merchandise exports) in Norway in 2004 to that in 2005?
Make the answer very short. 1.04. What is the ratio of the Imports(as % of merchandise exports) in Middle income in 2004 to that in 2006?
Provide a succinct answer. 0.82. What is the ratio of the Imports(as % of merchandise exports) of Denmark in 2004 to that in 2006?
Give a very brief answer. 0.89. What is the ratio of the Imports(as % of merchandise exports) of Gabon in 2004 to that in 2006?
Provide a short and direct response. 0.82. What is the ratio of the Imports(as % of merchandise exports) in Norway in 2004 to that in 2006?
Offer a very short reply. 0.96. What is the ratio of the Imports(as % of merchandise exports) in Middle income in 2004 to that in 2007?
Offer a very short reply. 0.82. What is the ratio of the Imports(as % of merchandise exports) of Denmark in 2004 to that in 2007?
Your answer should be compact. 1.06. What is the ratio of the Imports(as % of merchandise exports) of Gabon in 2004 to that in 2007?
Offer a very short reply. 0.66. What is the ratio of the Imports(as % of merchandise exports) of Norway in 2004 to that in 2007?
Offer a terse response. 1.03. What is the ratio of the Imports(as % of merchandise exports) of Middle income in 2005 to that in 2006?
Make the answer very short. 0.93. What is the ratio of the Imports(as % of merchandise exports) in Denmark in 2005 to that in 2006?
Ensure brevity in your answer.  1.15. What is the ratio of the Imports(as % of merchandise exports) of Gabon in 2005 to that in 2006?
Keep it short and to the point. 0.93. What is the ratio of the Imports(as % of merchandise exports) of Norway in 2005 to that in 2006?
Offer a terse response. 0.92. What is the ratio of the Imports(as % of merchandise exports) of Middle income in 2005 to that in 2007?
Your answer should be very brief. 0.93. What is the ratio of the Imports(as % of merchandise exports) in Denmark in 2005 to that in 2007?
Your response must be concise. 1.36. What is the ratio of the Imports(as % of merchandise exports) of Gabon in 2005 to that in 2007?
Offer a very short reply. 0.75. What is the ratio of the Imports(as % of merchandise exports) of Denmark in 2006 to that in 2007?
Offer a very short reply. 1.19. What is the ratio of the Imports(as % of merchandise exports) in Gabon in 2006 to that in 2007?
Provide a succinct answer. 0.8. What is the ratio of the Imports(as % of merchandise exports) in Norway in 2006 to that in 2007?
Your answer should be very brief. 1.07. What is the difference between the highest and the second highest Imports(as % of merchandise exports) in Middle income?
Provide a short and direct response. 0.07. What is the difference between the highest and the second highest Imports(as % of merchandise exports) of Denmark?
Your answer should be compact. 0.89. What is the difference between the highest and the second highest Imports(as % of merchandise exports) of Gabon?
Provide a short and direct response. 0.96. What is the difference between the highest and the second highest Imports(as % of merchandise exports) in Norway?
Your response must be concise. 0.11. What is the difference between the highest and the lowest Imports(as % of merchandise exports) of Middle income?
Offer a very short reply. 4.62. What is the difference between the highest and the lowest Imports(as % of merchandise exports) of Denmark?
Your answer should be compact. 2.46. What is the difference between the highest and the lowest Imports(as % of merchandise exports) in Gabon?
Your response must be concise. 3.02. What is the difference between the highest and the lowest Imports(as % of merchandise exports) in Norway?
Provide a short and direct response. 1.07. 